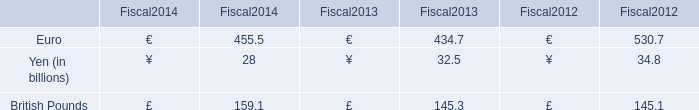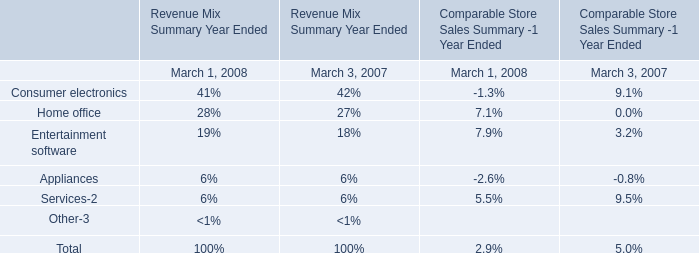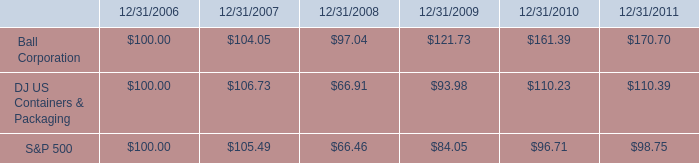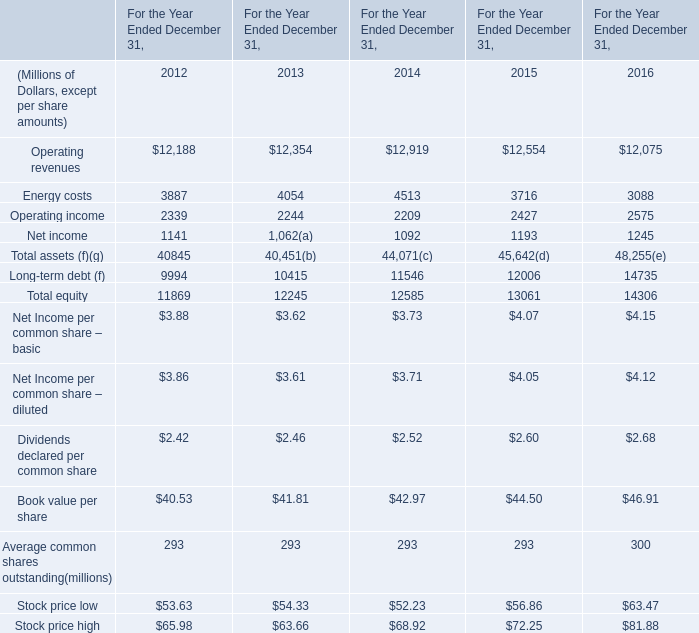What is the sum of Energy costs in 2012 ? (in million) 
Answer: 3887. 